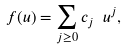Convert formula to latex. <formula><loc_0><loc_0><loc_500><loc_500>f ( u ) = \sum _ { j \geq 0 } c _ { j } \ u ^ { j } ,</formula> 